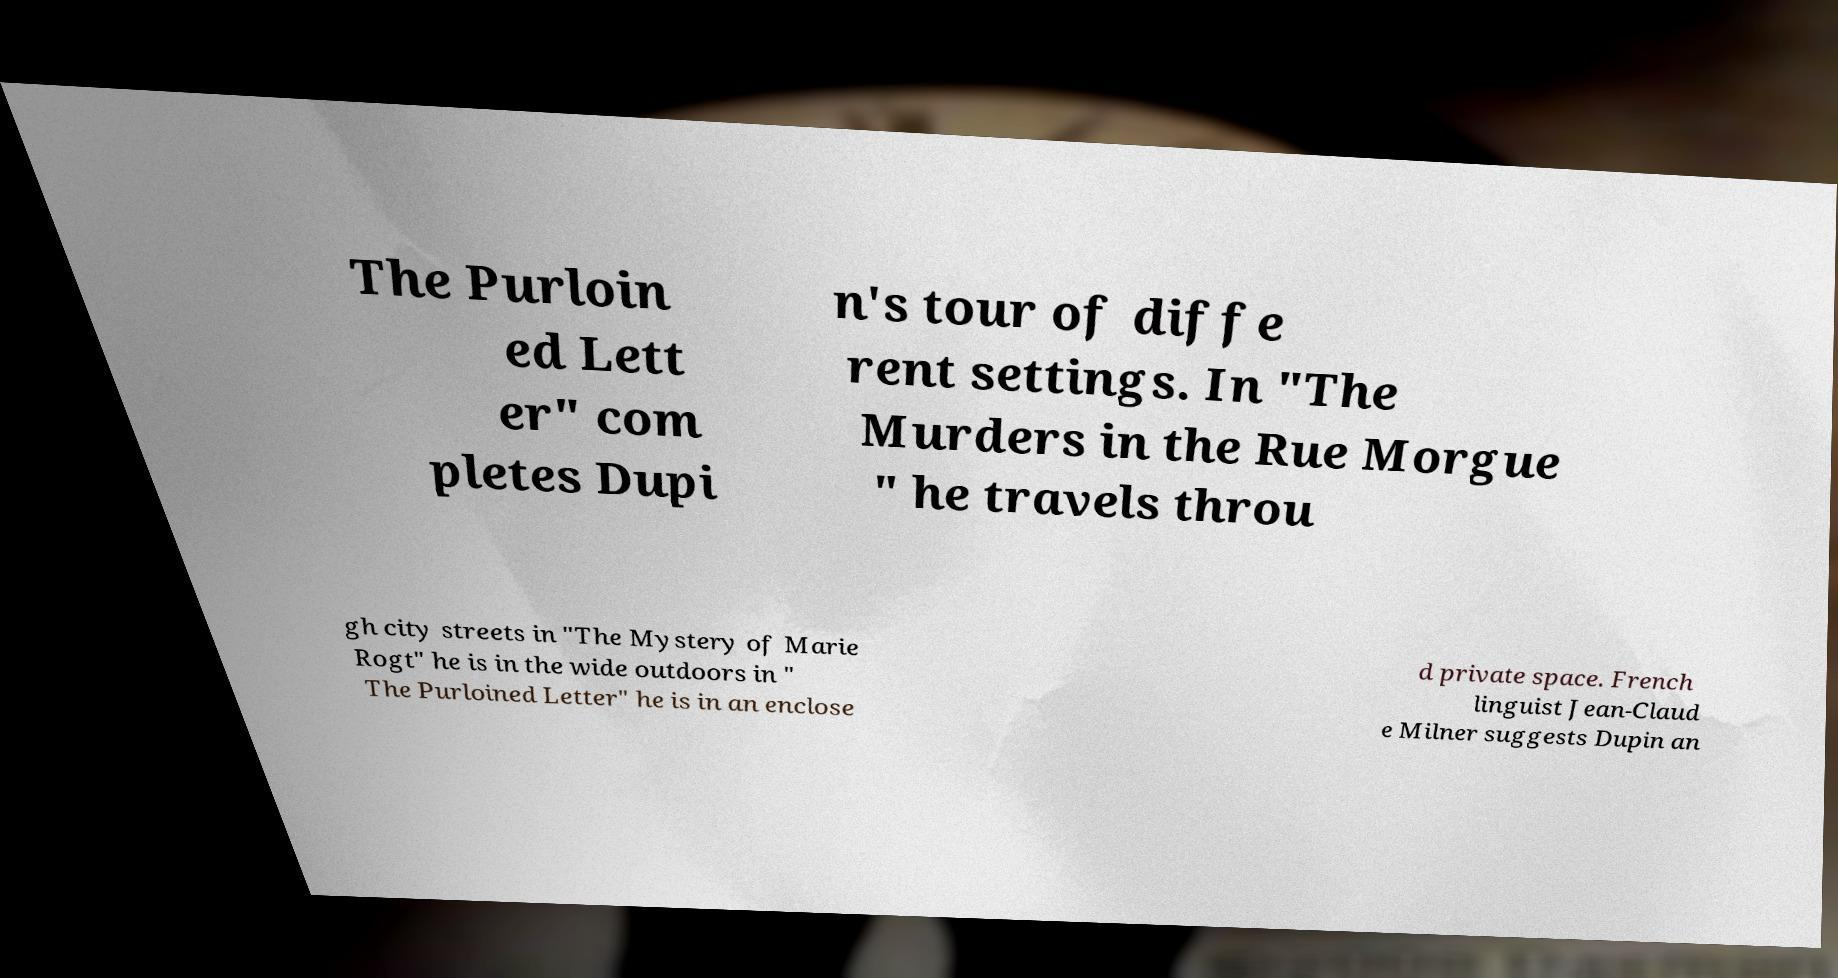Could you extract and type out the text from this image? The Purloin ed Lett er" com pletes Dupi n's tour of diffe rent settings. In "The Murders in the Rue Morgue " he travels throu gh city streets in "The Mystery of Marie Rogt" he is in the wide outdoors in " The Purloined Letter" he is in an enclose d private space. French linguist Jean-Claud e Milner suggests Dupin an 